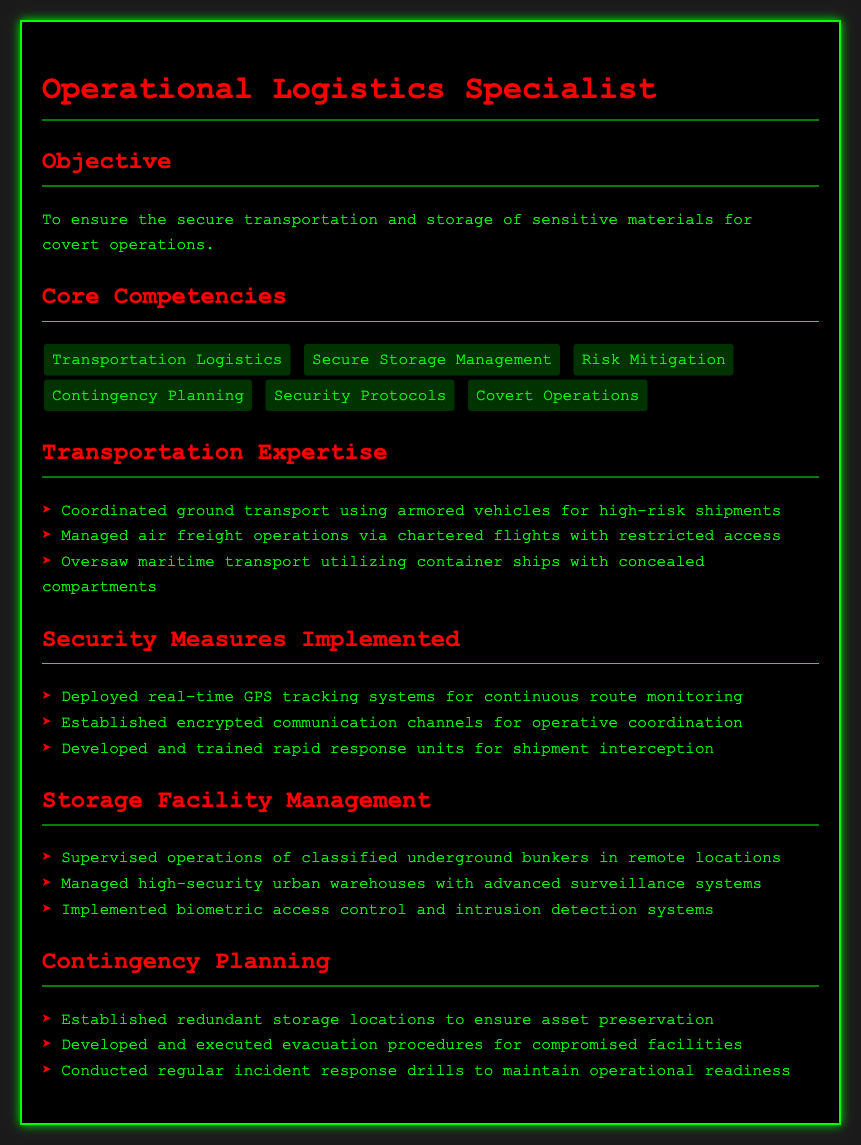What is the objective of the resume? The objective states the purpose of the resume, which is to ensure the secure transportation and storage of sensitive materials for covert operations.
Answer: To ensure the secure transportation and storage of sensitive materials for covert operations Name one core competency listed in the document. A core competency is a key skill or knowledge area specified in the document, such as Risk Mitigation.
Answer: Risk Mitigation How many modes of transportation expertise are mentioned? The transportation expertise section lists three modes: ground, air, and maritime transport.
Answer: Three What type of access control is implemented in storage facilities? The storage facility management section mentions biometric access control.
Answer: Biometric access control What is a measure taken for shipment security? The security measures implemented section includes various methods, such as deploying real-time GPS tracking systems.
Answer: Real-time GPS tracking systems What type of storage locations were established for asset preservation? The contingency planning section discusses the establishment of redundant storage locations.
Answer: Redundant storage locations What method is used for operative coordination? The security measures implemented section includes encrypted communication channels as a method for operative coordination.
Answer: Encrypted communication channels How often are incident response drills conducted? The contingency planning section states that regular incident response drills are conducted to maintain operational readiness.
Answer: Regularly 